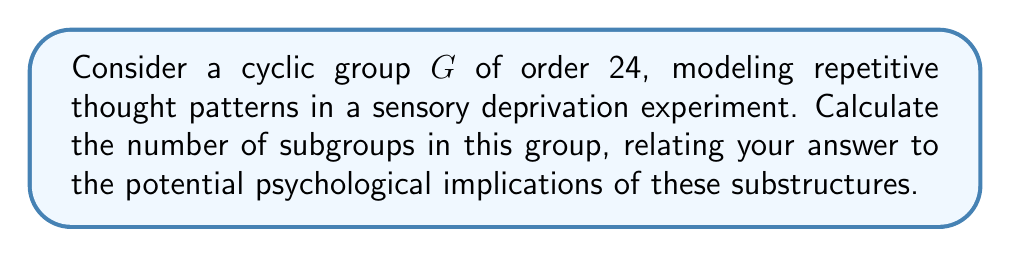Solve this math problem. To solve this problem, we'll follow these steps:

1) In a cyclic group of order $n$, the number of subgroups is equal to the number of divisors of $n$. This is because for each divisor $d$ of $n$, there is a unique subgroup of order $d$.

2) The divisors of 24 are: 1, 2, 3, 4, 6, 8, 12, and 24.

3) To find these divisors systematically:
   - Factors of 24: $24 = 2^3 \times 3$
   - Divisors: $(1+1+1+1) \times (1+1) = 4 \times 2 = 8$

4) Therefore, there are 8 subgroups in the cyclic group of order 24.

From a psychological perspective, this could be interpreted as follows:

- The main group (order 24) represents the full cycle of repetitive thoughts.
- Each subgroup represents a potential "sub-cycle" or pattern within the main thought process.
- The variety of subgroups (8 in total) suggests multiple levels of nested or interrelated thought patterns that might emerge during sensory deprivation.
- The largest proper subgroup (order 12) could represent a significant "half-cycle" pattern that might be particularly noticeable or dominant.
- The smallest non-trivial subgroup (order 2) might represent the most basic, binary oscillation in thought processes.

This mathematical structure provides a framework for analyzing the complexity and interconnectedness of repetitive thought patterns that may arise during sensory deprivation experiments.
Answer: The cyclic group of order 24 has 8 subgroups. 